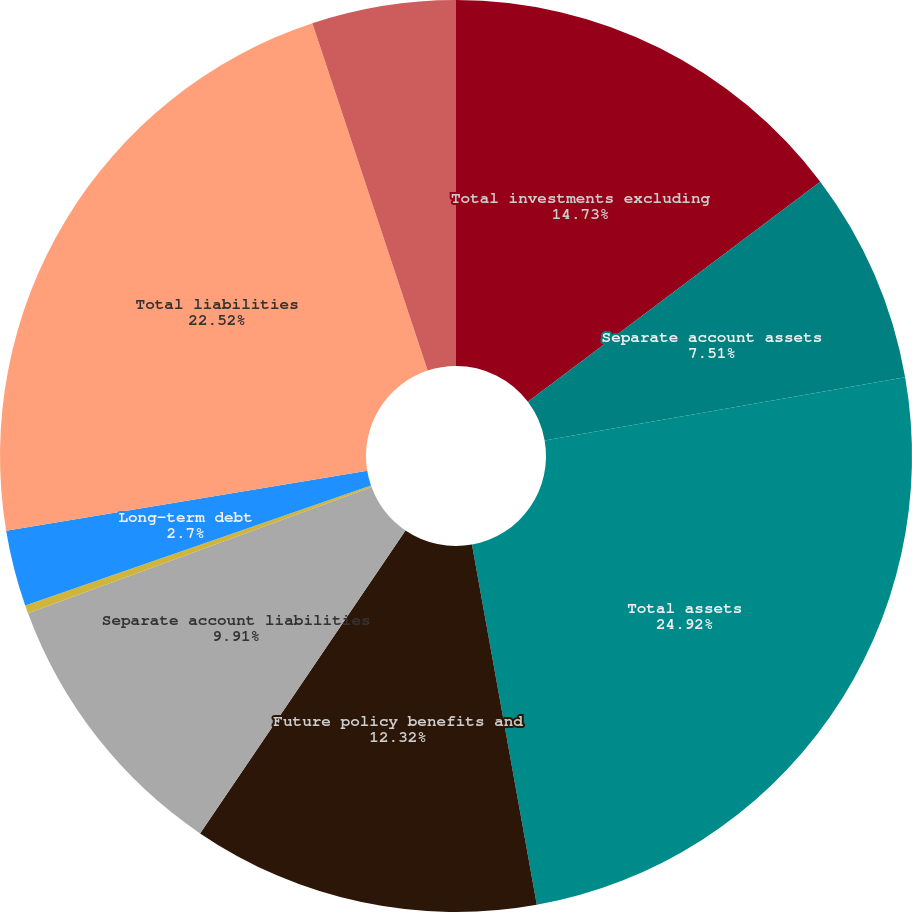Convert chart to OTSL. <chart><loc_0><loc_0><loc_500><loc_500><pie_chart><fcel>Total investments excluding<fcel>Separate account assets<fcel>Total assets<fcel>Future policy benefits and<fcel>Separate account liabilities<fcel>Short-term debt<fcel>Long-term debt<fcel>Total liabilities<fcel>Stockholders' equity<nl><fcel>14.73%<fcel>7.51%<fcel>24.93%<fcel>12.32%<fcel>9.91%<fcel>0.29%<fcel>2.7%<fcel>22.52%<fcel>5.1%<nl></chart> 